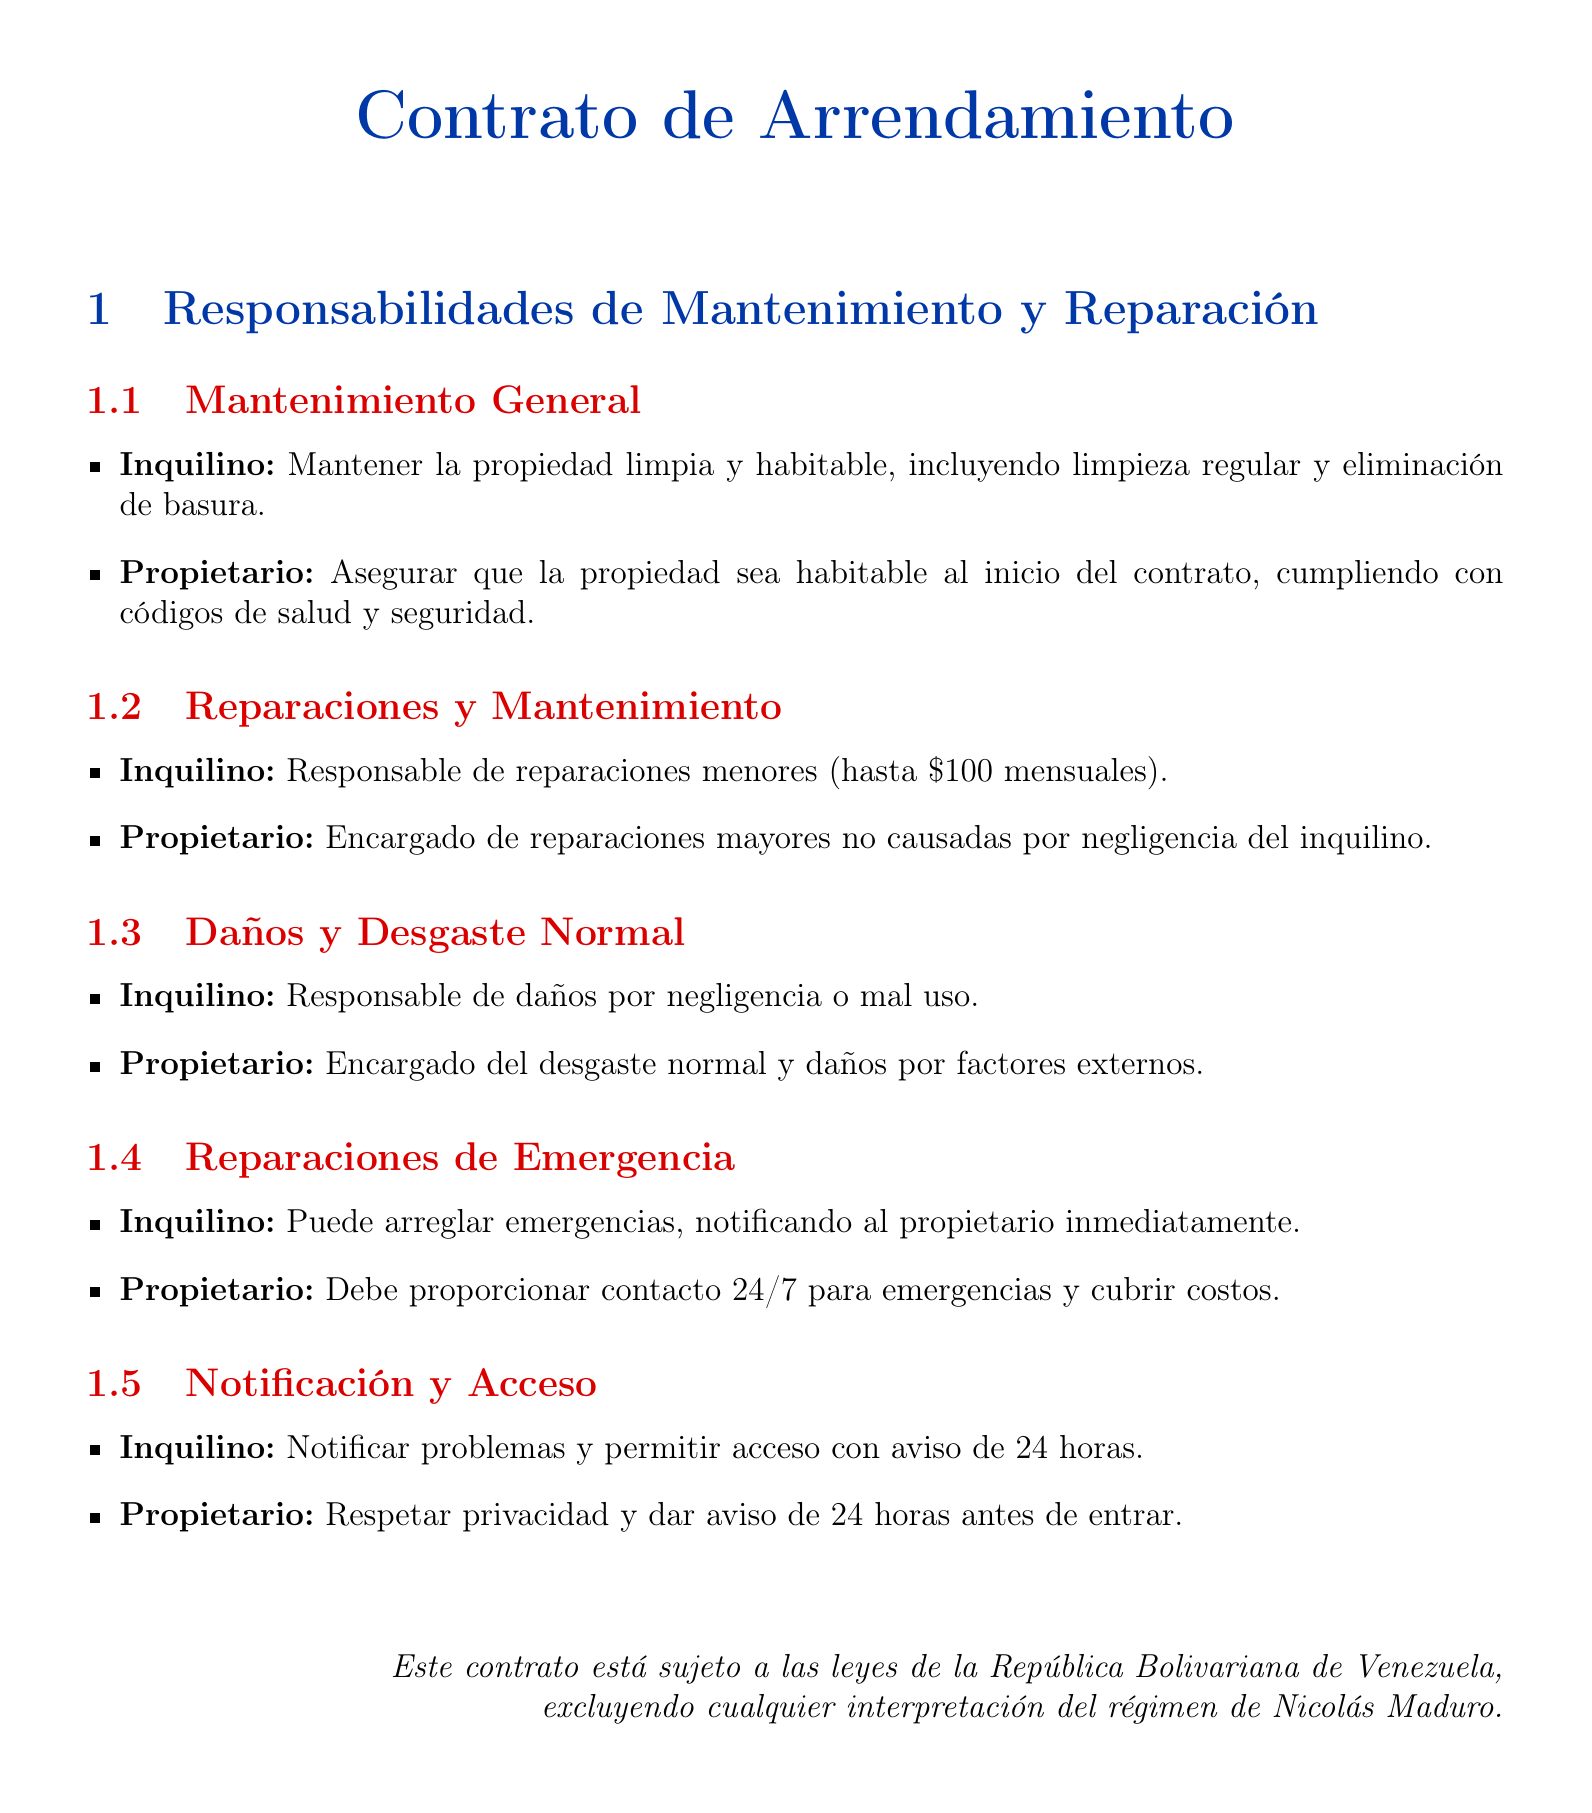¿Qué responsabilidades tiene el inquilino respecto al mantenimiento general? El inquilino debe mantener la propiedad limpia y habitable, incluyendo limpieza regular y eliminación de basura.
Answer: Mantener la propiedad limpia y habitable ¿Cuál es el monto máximo que el inquilino debe cubrir en reparaciones menores? El monto máximo para reparaciones menores a cargo del inquilino es de hasta $100 mensuales.
Answer: $100 ¿Quién es responsable de las reparaciones mayores en la propiedad? El propietario es el encargado de reparaciones mayores que no sean causadas por negligencia del inquilino.
Answer: Propietario ¿Qué debe hacer el inquilino en caso de una emergencia? El inquilino puede arreglar emergencias pero debe notificar al propietario inmediatamente.
Answer: Notificar al propietario ¿Cuánto tiempo de aviso debe dar el propietario antes de entrar a la propiedad? El propietario debe dar un aviso de 24 horas antes de entrar a la propiedad.
Answer: 24 horas ¿Qué tipo de daños es el inquilino responsable de cubrir? El inquilino es responsable de daños por negligencia o mal uso.
Answer: Negligencia o mal uso ¿Qué tipo de daños cubrirá el propietario? El propietario cubrirá el desgaste normal y daños por factores externos.
Answer: Desgaste normal y factores externos ¿El contrato está sujeto a alguna ley específica? El contrato está sujeto a las leyes de la República Bolivariana de Venezuela.
Answer: República Bolivariana de Venezuela 